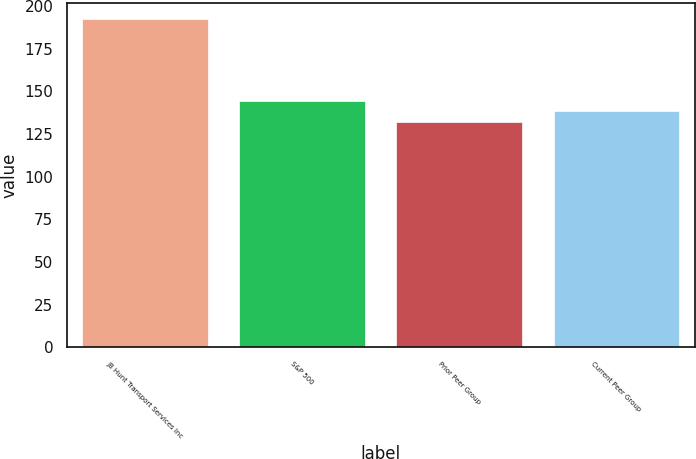Convert chart to OTSL. <chart><loc_0><loc_0><loc_500><loc_500><bar_chart><fcel>JB Hunt Transport Services Inc<fcel>S&P 500<fcel>Prior Peer Group<fcel>Current Peer Group<nl><fcel>192.26<fcel>144.26<fcel>132.26<fcel>138.26<nl></chart> 